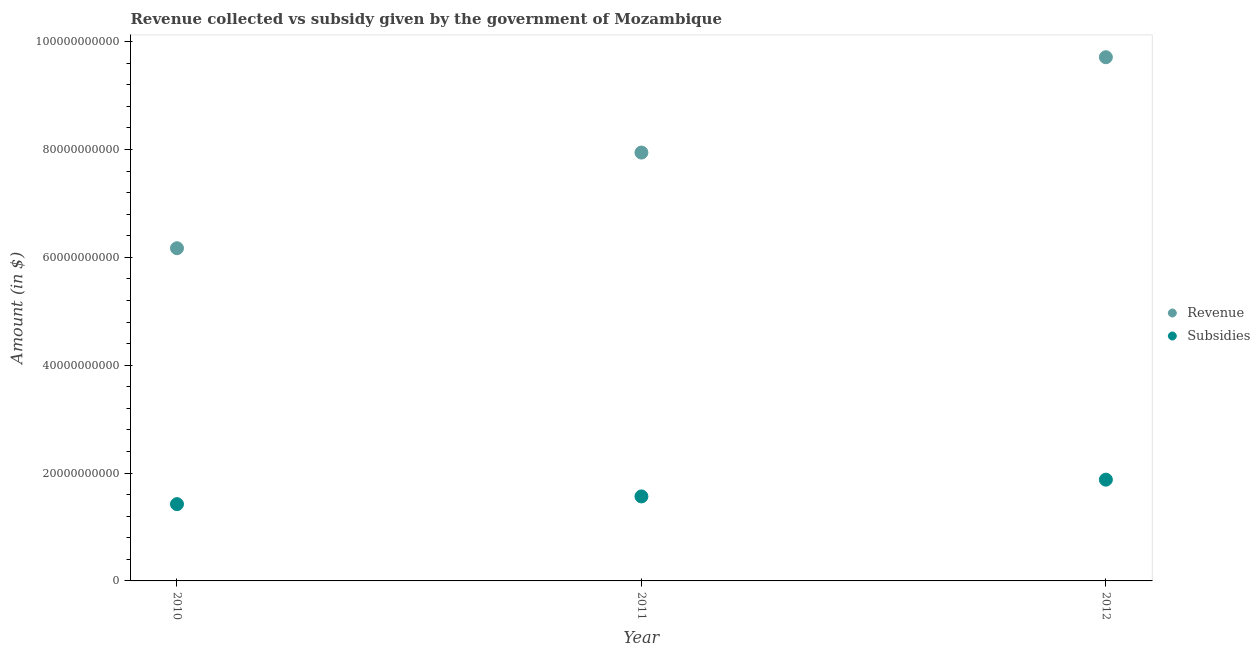How many different coloured dotlines are there?
Keep it short and to the point. 2. Is the number of dotlines equal to the number of legend labels?
Provide a succinct answer. Yes. What is the amount of subsidies given in 2011?
Ensure brevity in your answer.  1.57e+1. Across all years, what is the maximum amount of revenue collected?
Provide a succinct answer. 9.71e+1. Across all years, what is the minimum amount of subsidies given?
Ensure brevity in your answer.  1.42e+1. In which year was the amount of revenue collected maximum?
Provide a short and direct response. 2012. In which year was the amount of subsidies given minimum?
Provide a succinct answer. 2010. What is the total amount of subsidies given in the graph?
Give a very brief answer. 4.87e+1. What is the difference between the amount of revenue collected in 2010 and that in 2012?
Your answer should be very brief. -3.54e+1. What is the difference between the amount of revenue collected in 2011 and the amount of subsidies given in 2012?
Your answer should be compact. 6.07e+1. What is the average amount of subsidies given per year?
Your response must be concise. 1.62e+1. In the year 2010, what is the difference between the amount of revenue collected and amount of subsidies given?
Your response must be concise. 4.75e+1. In how many years, is the amount of revenue collected greater than 60000000000 $?
Your answer should be compact. 3. What is the ratio of the amount of subsidies given in 2010 to that in 2012?
Your response must be concise. 0.76. Is the amount of subsidies given in 2010 less than that in 2012?
Your answer should be compact. Yes. What is the difference between the highest and the second highest amount of revenue collected?
Ensure brevity in your answer.  1.77e+1. What is the difference between the highest and the lowest amount of revenue collected?
Provide a succinct answer. 3.54e+1. In how many years, is the amount of subsidies given greater than the average amount of subsidies given taken over all years?
Offer a terse response. 1. Is the sum of the amount of revenue collected in 2011 and 2012 greater than the maximum amount of subsidies given across all years?
Keep it short and to the point. Yes. How are the legend labels stacked?
Your answer should be compact. Vertical. What is the title of the graph?
Ensure brevity in your answer.  Revenue collected vs subsidy given by the government of Mozambique. What is the label or title of the X-axis?
Make the answer very short. Year. What is the label or title of the Y-axis?
Give a very brief answer. Amount (in $). What is the Amount (in $) in Revenue in 2010?
Keep it short and to the point. 6.17e+1. What is the Amount (in $) in Subsidies in 2010?
Your answer should be compact. 1.42e+1. What is the Amount (in $) of Revenue in 2011?
Provide a succinct answer. 7.94e+1. What is the Amount (in $) of Subsidies in 2011?
Your response must be concise. 1.57e+1. What is the Amount (in $) in Revenue in 2012?
Your response must be concise. 9.71e+1. What is the Amount (in $) of Subsidies in 2012?
Offer a very short reply. 1.88e+1. Across all years, what is the maximum Amount (in $) of Revenue?
Your response must be concise. 9.71e+1. Across all years, what is the maximum Amount (in $) in Subsidies?
Keep it short and to the point. 1.88e+1. Across all years, what is the minimum Amount (in $) of Revenue?
Provide a short and direct response. 6.17e+1. Across all years, what is the minimum Amount (in $) of Subsidies?
Offer a very short reply. 1.42e+1. What is the total Amount (in $) in Revenue in the graph?
Offer a terse response. 2.38e+11. What is the total Amount (in $) in Subsidies in the graph?
Your response must be concise. 4.87e+1. What is the difference between the Amount (in $) of Revenue in 2010 and that in 2011?
Give a very brief answer. -1.77e+1. What is the difference between the Amount (in $) of Subsidies in 2010 and that in 2011?
Your response must be concise. -1.43e+09. What is the difference between the Amount (in $) in Revenue in 2010 and that in 2012?
Ensure brevity in your answer.  -3.54e+1. What is the difference between the Amount (in $) of Subsidies in 2010 and that in 2012?
Provide a succinct answer. -4.54e+09. What is the difference between the Amount (in $) in Revenue in 2011 and that in 2012?
Your answer should be compact. -1.77e+1. What is the difference between the Amount (in $) of Subsidies in 2011 and that in 2012?
Your answer should be very brief. -3.11e+09. What is the difference between the Amount (in $) in Revenue in 2010 and the Amount (in $) in Subsidies in 2011?
Provide a short and direct response. 4.60e+1. What is the difference between the Amount (in $) of Revenue in 2010 and the Amount (in $) of Subsidies in 2012?
Ensure brevity in your answer.  4.29e+1. What is the difference between the Amount (in $) of Revenue in 2011 and the Amount (in $) of Subsidies in 2012?
Ensure brevity in your answer.  6.07e+1. What is the average Amount (in $) in Revenue per year?
Keep it short and to the point. 7.94e+1. What is the average Amount (in $) in Subsidies per year?
Your response must be concise. 1.62e+1. In the year 2010, what is the difference between the Amount (in $) of Revenue and Amount (in $) of Subsidies?
Your answer should be compact. 4.75e+1. In the year 2011, what is the difference between the Amount (in $) of Revenue and Amount (in $) of Subsidies?
Give a very brief answer. 6.38e+1. In the year 2012, what is the difference between the Amount (in $) of Revenue and Amount (in $) of Subsidies?
Provide a succinct answer. 7.83e+1. What is the ratio of the Amount (in $) of Revenue in 2010 to that in 2011?
Make the answer very short. 0.78. What is the ratio of the Amount (in $) of Subsidies in 2010 to that in 2011?
Provide a short and direct response. 0.91. What is the ratio of the Amount (in $) in Revenue in 2010 to that in 2012?
Provide a short and direct response. 0.64. What is the ratio of the Amount (in $) in Subsidies in 2010 to that in 2012?
Keep it short and to the point. 0.76. What is the ratio of the Amount (in $) in Revenue in 2011 to that in 2012?
Keep it short and to the point. 0.82. What is the ratio of the Amount (in $) of Subsidies in 2011 to that in 2012?
Provide a succinct answer. 0.83. What is the difference between the highest and the second highest Amount (in $) of Revenue?
Make the answer very short. 1.77e+1. What is the difference between the highest and the second highest Amount (in $) in Subsidies?
Make the answer very short. 3.11e+09. What is the difference between the highest and the lowest Amount (in $) in Revenue?
Make the answer very short. 3.54e+1. What is the difference between the highest and the lowest Amount (in $) of Subsidies?
Make the answer very short. 4.54e+09. 